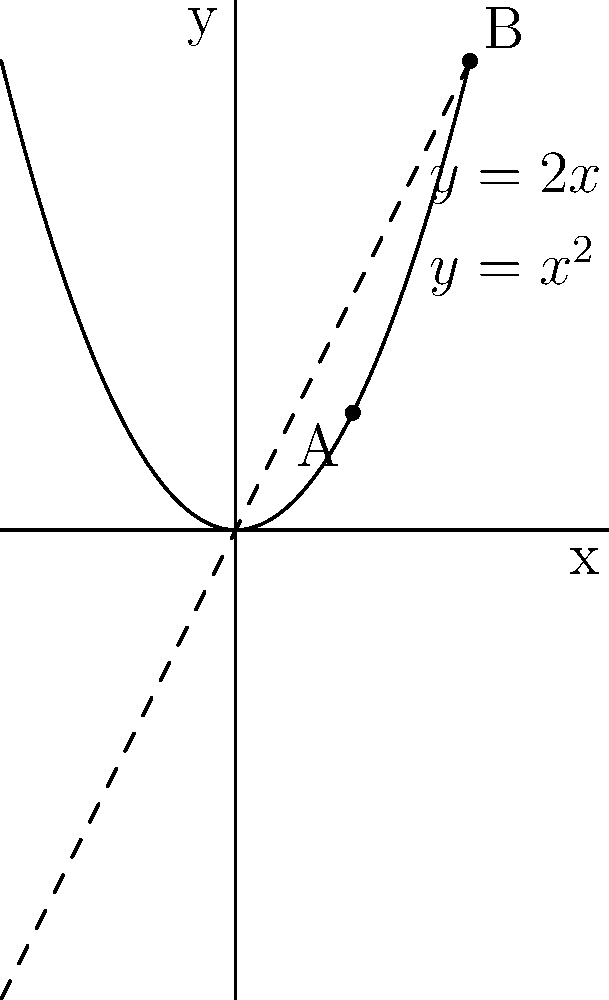In the Half Bad series, Nathan's magical abilities are represented by the function $f(x)=x^2$, while Gabriel's are represented by $g(x)=2x$. Their combined power at a given point is the vertical distance between these two functions. At what x-coordinate does their combined power reach its maximum within the interval $[0,2]$? To find the maximum combined power, we need to follow these steps:

1) The combined power is represented by the difference between $f(x)$ and $g(x)$:
   $h(x) = f(x) - g(x) = x^2 - 2x$

2) To find the maximum, we need to find where the derivative of $h(x)$ equals zero:
   $h'(x) = 2x - 2$
   Set $h'(x) = 0$:
   $2x - 2 = 0$
   $2x = 2$
   $x = 1$

3) We need to verify this is a maximum, not a minimum:
   $h''(x) = 2 > 0$, so $x=1$ is indeed a local maximum.

4) We also need to check the endpoints of the interval $[0,2]$:
   $h(0) = 0^2 - 2(0) = 0$
   $h(1) = 1^2 - 2(1) = -1$
   $h(2) = 2^2 - 2(2) = 0$

5) The maximum value occurs at $x=1$, which is within our interval and greater than the values at the endpoints.

Therefore, the combined power reaches its maximum at $x=1$.
Answer: 1 